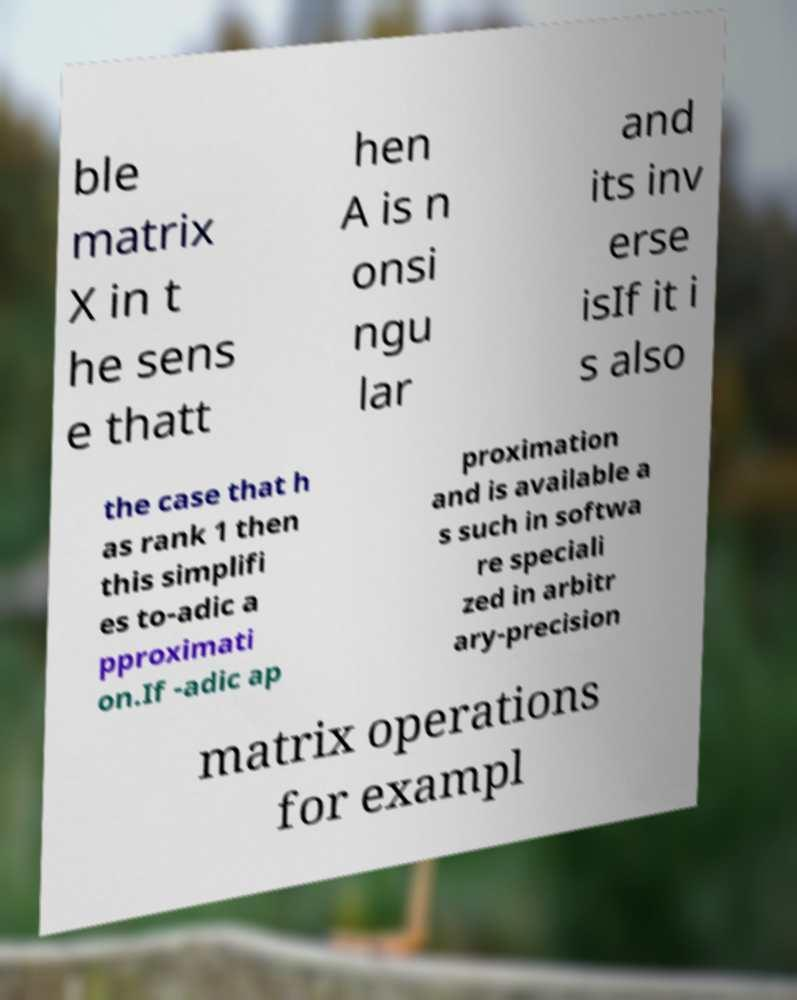For documentation purposes, I need the text within this image transcribed. Could you provide that? ble matrix X in t he sens e thatt hen A is n onsi ngu lar and its inv erse isIf it i s also the case that h as rank 1 then this simplifi es to-adic a pproximati on.If -adic ap proximation and is available a s such in softwa re speciali zed in arbitr ary-precision matrix operations for exampl 